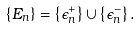Convert formula to latex. <formula><loc_0><loc_0><loc_500><loc_500>\left \{ E _ { n } \right \} = \left \{ \epsilon _ { n } ^ { + } \right \} \cup \left \{ \epsilon _ { n } ^ { - } \right \} .</formula> 